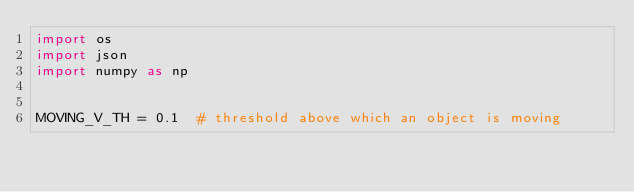<code> <loc_0><loc_0><loc_500><loc_500><_Python_>import os
import json
import numpy as np


MOVING_V_TH = 0.1  # threshold above which an object is moving</code> 